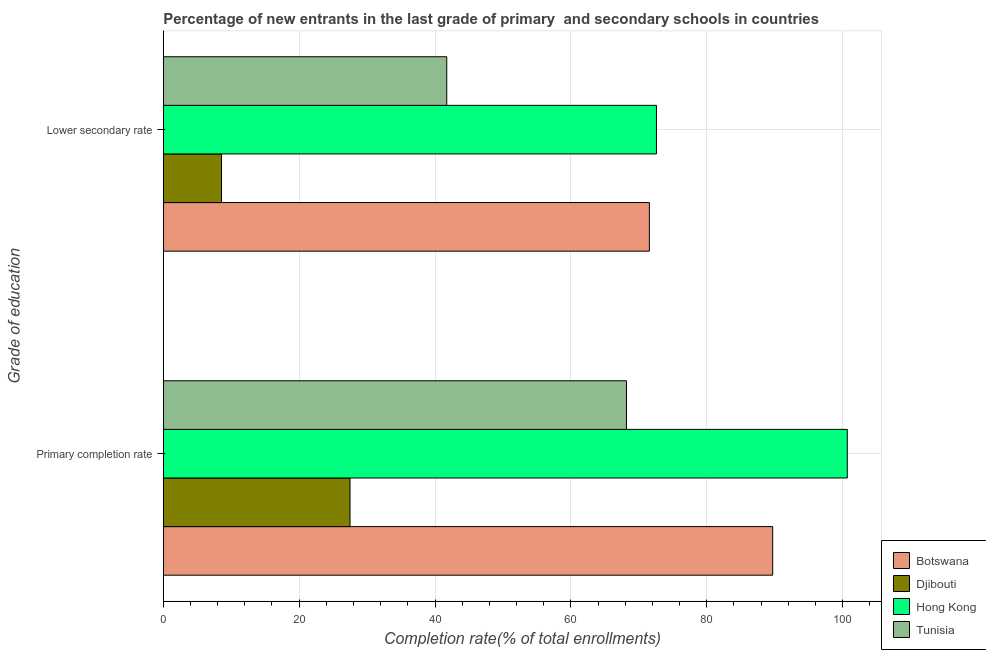How many different coloured bars are there?
Your response must be concise. 4. How many groups of bars are there?
Your answer should be very brief. 2. How many bars are there on the 2nd tick from the top?
Offer a very short reply. 4. What is the label of the 1st group of bars from the top?
Your answer should be compact. Lower secondary rate. What is the completion rate in secondary schools in Hong Kong?
Ensure brevity in your answer.  72.6. Across all countries, what is the maximum completion rate in primary schools?
Your answer should be very brief. 100.69. Across all countries, what is the minimum completion rate in secondary schools?
Give a very brief answer. 8.57. In which country was the completion rate in primary schools maximum?
Your answer should be very brief. Hong Kong. In which country was the completion rate in secondary schools minimum?
Ensure brevity in your answer.  Djibouti. What is the total completion rate in secondary schools in the graph?
Ensure brevity in your answer.  194.45. What is the difference between the completion rate in primary schools in Tunisia and that in Hong Kong?
Your response must be concise. -32.51. What is the difference between the completion rate in secondary schools in Hong Kong and the completion rate in primary schools in Djibouti?
Offer a very short reply. 45.11. What is the average completion rate in primary schools per country?
Keep it short and to the point. 71.52. What is the difference between the completion rate in secondary schools and completion rate in primary schools in Tunisia?
Your answer should be compact. -26.45. In how many countries, is the completion rate in secondary schools greater than 16 %?
Your answer should be very brief. 3. What is the ratio of the completion rate in primary schools in Hong Kong to that in Botswana?
Keep it short and to the point. 1.12. Is the completion rate in primary schools in Tunisia less than that in Botswana?
Make the answer very short. Yes. What does the 4th bar from the top in Primary completion rate represents?
Offer a terse response. Botswana. What does the 4th bar from the bottom in Lower secondary rate represents?
Keep it short and to the point. Tunisia. How many countries are there in the graph?
Offer a terse response. 4. What is the difference between two consecutive major ticks on the X-axis?
Offer a very short reply. 20. Where does the legend appear in the graph?
Your response must be concise. Bottom right. How are the legend labels stacked?
Make the answer very short. Vertical. What is the title of the graph?
Keep it short and to the point. Percentage of new entrants in the last grade of primary  and secondary schools in countries. What is the label or title of the X-axis?
Your response must be concise. Completion rate(% of total enrollments). What is the label or title of the Y-axis?
Make the answer very short. Grade of education. What is the Completion rate(% of total enrollments) of Botswana in Primary completion rate?
Offer a terse response. 89.71. What is the Completion rate(% of total enrollments) in Djibouti in Primary completion rate?
Your answer should be compact. 27.49. What is the Completion rate(% of total enrollments) of Hong Kong in Primary completion rate?
Your answer should be compact. 100.69. What is the Completion rate(% of total enrollments) of Tunisia in Primary completion rate?
Provide a succinct answer. 68.18. What is the Completion rate(% of total enrollments) of Botswana in Lower secondary rate?
Make the answer very short. 71.55. What is the Completion rate(% of total enrollments) of Djibouti in Lower secondary rate?
Your answer should be very brief. 8.57. What is the Completion rate(% of total enrollments) in Hong Kong in Lower secondary rate?
Your response must be concise. 72.6. What is the Completion rate(% of total enrollments) in Tunisia in Lower secondary rate?
Provide a short and direct response. 41.73. Across all Grade of education, what is the maximum Completion rate(% of total enrollments) of Botswana?
Give a very brief answer. 89.71. Across all Grade of education, what is the maximum Completion rate(% of total enrollments) in Djibouti?
Keep it short and to the point. 27.49. Across all Grade of education, what is the maximum Completion rate(% of total enrollments) in Hong Kong?
Your answer should be compact. 100.69. Across all Grade of education, what is the maximum Completion rate(% of total enrollments) in Tunisia?
Keep it short and to the point. 68.18. Across all Grade of education, what is the minimum Completion rate(% of total enrollments) in Botswana?
Give a very brief answer. 71.55. Across all Grade of education, what is the minimum Completion rate(% of total enrollments) of Djibouti?
Provide a short and direct response. 8.57. Across all Grade of education, what is the minimum Completion rate(% of total enrollments) in Hong Kong?
Provide a short and direct response. 72.6. Across all Grade of education, what is the minimum Completion rate(% of total enrollments) of Tunisia?
Offer a terse response. 41.73. What is the total Completion rate(% of total enrollments) in Botswana in the graph?
Your answer should be very brief. 161.26. What is the total Completion rate(% of total enrollments) of Djibouti in the graph?
Keep it short and to the point. 36.06. What is the total Completion rate(% of total enrollments) of Hong Kong in the graph?
Make the answer very short. 173.28. What is the total Completion rate(% of total enrollments) of Tunisia in the graph?
Your answer should be very brief. 109.91. What is the difference between the Completion rate(% of total enrollments) of Botswana in Primary completion rate and that in Lower secondary rate?
Keep it short and to the point. 18.15. What is the difference between the Completion rate(% of total enrollments) of Djibouti in Primary completion rate and that in Lower secondary rate?
Keep it short and to the point. 18.92. What is the difference between the Completion rate(% of total enrollments) in Hong Kong in Primary completion rate and that in Lower secondary rate?
Make the answer very short. 28.09. What is the difference between the Completion rate(% of total enrollments) in Tunisia in Primary completion rate and that in Lower secondary rate?
Offer a very short reply. 26.45. What is the difference between the Completion rate(% of total enrollments) in Botswana in Primary completion rate and the Completion rate(% of total enrollments) in Djibouti in Lower secondary rate?
Provide a succinct answer. 81.13. What is the difference between the Completion rate(% of total enrollments) in Botswana in Primary completion rate and the Completion rate(% of total enrollments) in Hong Kong in Lower secondary rate?
Your response must be concise. 17.11. What is the difference between the Completion rate(% of total enrollments) in Botswana in Primary completion rate and the Completion rate(% of total enrollments) in Tunisia in Lower secondary rate?
Give a very brief answer. 47.98. What is the difference between the Completion rate(% of total enrollments) of Djibouti in Primary completion rate and the Completion rate(% of total enrollments) of Hong Kong in Lower secondary rate?
Provide a succinct answer. -45.11. What is the difference between the Completion rate(% of total enrollments) of Djibouti in Primary completion rate and the Completion rate(% of total enrollments) of Tunisia in Lower secondary rate?
Provide a succinct answer. -14.24. What is the difference between the Completion rate(% of total enrollments) of Hong Kong in Primary completion rate and the Completion rate(% of total enrollments) of Tunisia in Lower secondary rate?
Your answer should be very brief. 58.96. What is the average Completion rate(% of total enrollments) of Botswana per Grade of education?
Make the answer very short. 80.63. What is the average Completion rate(% of total enrollments) of Djibouti per Grade of education?
Your answer should be very brief. 18.03. What is the average Completion rate(% of total enrollments) of Hong Kong per Grade of education?
Your response must be concise. 86.64. What is the average Completion rate(% of total enrollments) of Tunisia per Grade of education?
Give a very brief answer. 54.95. What is the difference between the Completion rate(% of total enrollments) in Botswana and Completion rate(% of total enrollments) in Djibouti in Primary completion rate?
Keep it short and to the point. 62.22. What is the difference between the Completion rate(% of total enrollments) in Botswana and Completion rate(% of total enrollments) in Hong Kong in Primary completion rate?
Ensure brevity in your answer.  -10.98. What is the difference between the Completion rate(% of total enrollments) of Botswana and Completion rate(% of total enrollments) of Tunisia in Primary completion rate?
Offer a terse response. 21.53. What is the difference between the Completion rate(% of total enrollments) in Djibouti and Completion rate(% of total enrollments) in Hong Kong in Primary completion rate?
Keep it short and to the point. -73.2. What is the difference between the Completion rate(% of total enrollments) of Djibouti and Completion rate(% of total enrollments) of Tunisia in Primary completion rate?
Your answer should be very brief. -40.69. What is the difference between the Completion rate(% of total enrollments) in Hong Kong and Completion rate(% of total enrollments) in Tunisia in Primary completion rate?
Offer a very short reply. 32.51. What is the difference between the Completion rate(% of total enrollments) of Botswana and Completion rate(% of total enrollments) of Djibouti in Lower secondary rate?
Your response must be concise. 62.98. What is the difference between the Completion rate(% of total enrollments) in Botswana and Completion rate(% of total enrollments) in Hong Kong in Lower secondary rate?
Your response must be concise. -1.04. What is the difference between the Completion rate(% of total enrollments) in Botswana and Completion rate(% of total enrollments) in Tunisia in Lower secondary rate?
Keep it short and to the point. 29.83. What is the difference between the Completion rate(% of total enrollments) of Djibouti and Completion rate(% of total enrollments) of Hong Kong in Lower secondary rate?
Make the answer very short. -64.02. What is the difference between the Completion rate(% of total enrollments) in Djibouti and Completion rate(% of total enrollments) in Tunisia in Lower secondary rate?
Give a very brief answer. -33.15. What is the difference between the Completion rate(% of total enrollments) of Hong Kong and Completion rate(% of total enrollments) of Tunisia in Lower secondary rate?
Your answer should be very brief. 30.87. What is the ratio of the Completion rate(% of total enrollments) of Botswana in Primary completion rate to that in Lower secondary rate?
Your answer should be very brief. 1.25. What is the ratio of the Completion rate(% of total enrollments) of Djibouti in Primary completion rate to that in Lower secondary rate?
Offer a terse response. 3.21. What is the ratio of the Completion rate(% of total enrollments) in Hong Kong in Primary completion rate to that in Lower secondary rate?
Your response must be concise. 1.39. What is the ratio of the Completion rate(% of total enrollments) in Tunisia in Primary completion rate to that in Lower secondary rate?
Your answer should be compact. 1.63. What is the difference between the highest and the second highest Completion rate(% of total enrollments) of Botswana?
Give a very brief answer. 18.15. What is the difference between the highest and the second highest Completion rate(% of total enrollments) of Djibouti?
Your answer should be compact. 18.92. What is the difference between the highest and the second highest Completion rate(% of total enrollments) of Hong Kong?
Offer a very short reply. 28.09. What is the difference between the highest and the second highest Completion rate(% of total enrollments) in Tunisia?
Your answer should be compact. 26.45. What is the difference between the highest and the lowest Completion rate(% of total enrollments) of Botswana?
Ensure brevity in your answer.  18.15. What is the difference between the highest and the lowest Completion rate(% of total enrollments) of Djibouti?
Ensure brevity in your answer.  18.92. What is the difference between the highest and the lowest Completion rate(% of total enrollments) in Hong Kong?
Your answer should be compact. 28.09. What is the difference between the highest and the lowest Completion rate(% of total enrollments) of Tunisia?
Provide a short and direct response. 26.45. 